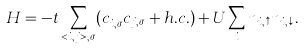Convert formula to latex. <formula><loc_0><loc_0><loc_500><loc_500>H = - t \sum _ { < i , j > , \sigma } ( c ^ { \dagger } _ { i , \sigma } c _ { j , \sigma } + h . c . ) + U \sum _ { i } n _ { i , \uparrow } n _ { i , \downarrow } .</formula> 